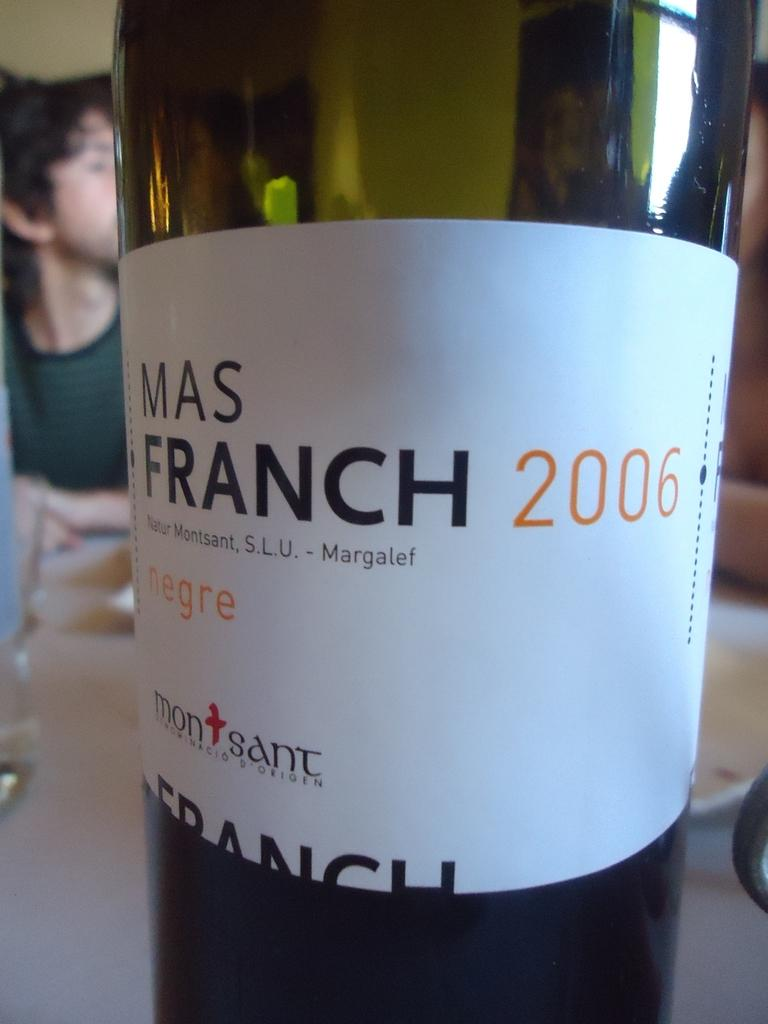<image>
Offer a succinct explanation of the picture presented. Mas Franch wine 2006 is sitting on a table. 